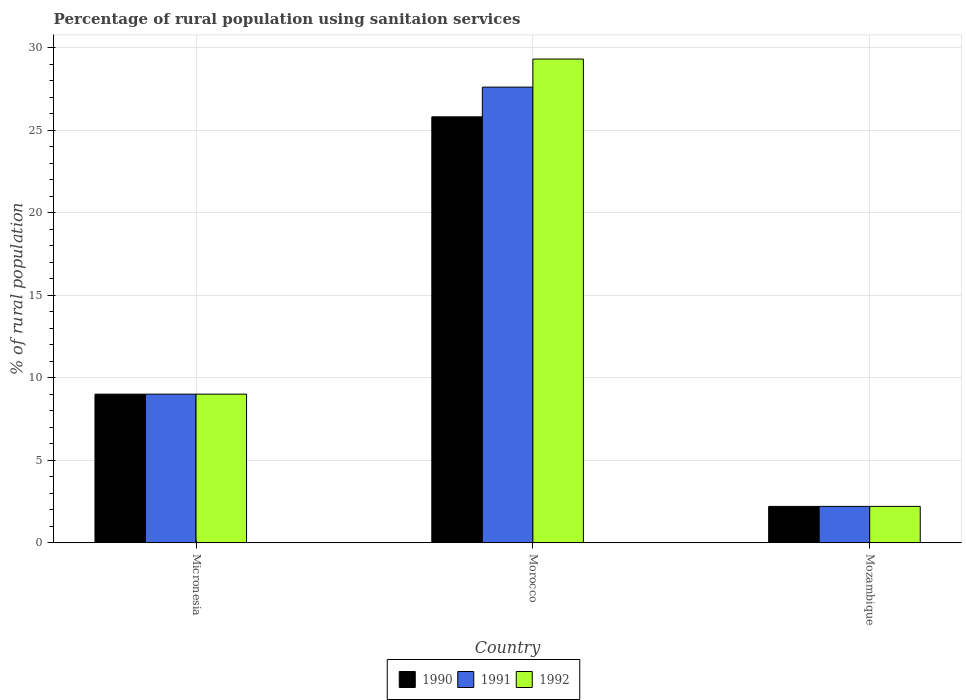How many groups of bars are there?
Your answer should be very brief. 3. How many bars are there on the 1st tick from the left?
Your answer should be very brief. 3. How many bars are there on the 2nd tick from the right?
Your answer should be compact. 3. What is the label of the 2nd group of bars from the left?
Your answer should be compact. Morocco. In how many cases, is the number of bars for a given country not equal to the number of legend labels?
Your answer should be very brief. 0. What is the percentage of rural population using sanitaion services in 1991 in Morocco?
Provide a short and direct response. 27.6. Across all countries, what is the maximum percentage of rural population using sanitaion services in 1992?
Your answer should be very brief. 29.3. In which country was the percentage of rural population using sanitaion services in 1990 maximum?
Your response must be concise. Morocco. In which country was the percentage of rural population using sanitaion services in 1990 minimum?
Offer a terse response. Mozambique. What is the total percentage of rural population using sanitaion services in 1990 in the graph?
Keep it short and to the point. 37. What is the difference between the percentage of rural population using sanitaion services in 1991 in Mozambique and the percentage of rural population using sanitaion services in 1990 in Morocco?
Your answer should be very brief. -23.6. What is the average percentage of rural population using sanitaion services in 1992 per country?
Your response must be concise. 13.5. What is the difference between the percentage of rural population using sanitaion services of/in 1992 and percentage of rural population using sanitaion services of/in 1990 in Mozambique?
Provide a succinct answer. 0. What is the ratio of the percentage of rural population using sanitaion services in 1992 in Morocco to that in Mozambique?
Provide a succinct answer. 13.32. What is the difference between the highest and the second highest percentage of rural population using sanitaion services in 1992?
Offer a very short reply. 6.8. What is the difference between the highest and the lowest percentage of rural population using sanitaion services in 1992?
Ensure brevity in your answer.  27.1. Is the sum of the percentage of rural population using sanitaion services in 1992 in Morocco and Mozambique greater than the maximum percentage of rural population using sanitaion services in 1990 across all countries?
Your answer should be very brief. Yes. What does the 1st bar from the right in Morocco represents?
Give a very brief answer. 1992. Is it the case that in every country, the sum of the percentage of rural population using sanitaion services in 1992 and percentage of rural population using sanitaion services in 1991 is greater than the percentage of rural population using sanitaion services in 1990?
Provide a succinct answer. Yes. Are all the bars in the graph horizontal?
Give a very brief answer. No. How many countries are there in the graph?
Your answer should be very brief. 3. What is the difference between two consecutive major ticks on the Y-axis?
Offer a terse response. 5. Are the values on the major ticks of Y-axis written in scientific E-notation?
Your answer should be compact. No. Does the graph contain any zero values?
Your answer should be very brief. No. How many legend labels are there?
Your answer should be very brief. 3. What is the title of the graph?
Ensure brevity in your answer.  Percentage of rural population using sanitaion services. Does "1990" appear as one of the legend labels in the graph?
Provide a short and direct response. Yes. What is the label or title of the X-axis?
Offer a terse response. Country. What is the label or title of the Y-axis?
Keep it short and to the point. % of rural population. What is the % of rural population of 1991 in Micronesia?
Provide a short and direct response. 9. What is the % of rural population of 1992 in Micronesia?
Provide a succinct answer. 9. What is the % of rural population in 1990 in Morocco?
Make the answer very short. 25.8. What is the % of rural population of 1991 in Morocco?
Give a very brief answer. 27.6. What is the % of rural population in 1992 in Morocco?
Provide a short and direct response. 29.3. What is the % of rural population of 1990 in Mozambique?
Your answer should be compact. 2.2. What is the % of rural population in 1991 in Mozambique?
Offer a terse response. 2.2. What is the % of rural population in 1992 in Mozambique?
Your response must be concise. 2.2. Across all countries, what is the maximum % of rural population in 1990?
Your response must be concise. 25.8. Across all countries, what is the maximum % of rural population in 1991?
Offer a terse response. 27.6. Across all countries, what is the maximum % of rural population in 1992?
Provide a succinct answer. 29.3. Across all countries, what is the minimum % of rural population in 1990?
Provide a succinct answer. 2.2. Across all countries, what is the minimum % of rural population in 1991?
Offer a terse response. 2.2. What is the total % of rural population of 1990 in the graph?
Give a very brief answer. 37. What is the total % of rural population in 1991 in the graph?
Provide a short and direct response. 38.8. What is the total % of rural population in 1992 in the graph?
Your answer should be compact. 40.5. What is the difference between the % of rural population of 1990 in Micronesia and that in Morocco?
Make the answer very short. -16.8. What is the difference between the % of rural population in 1991 in Micronesia and that in Morocco?
Provide a short and direct response. -18.6. What is the difference between the % of rural population of 1992 in Micronesia and that in Morocco?
Your response must be concise. -20.3. What is the difference between the % of rural population of 1990 in Micronesia and that in Mozambique?
Provide a short and direct response. 6.8. What is the difference between the % of rural population in 1991 in Micronesia and that in Mozambique?
Make the answer very short. 6.8. What is the difference between the % of rural population in 1990 in Morocco and that in Mozambique?
Your answer should be very brief. 23.6. What is the difference between the % of rural population of 1991 in Morocco and that in Mozambique?
Ensure brevity in your answer.  25.4. What is the difference between the % of rural population of 1992 in Morocco and that in Mozambique?
Provide a short and direct response. 27.1. What is the difference between the % of rural population of 1990 in Micronesia and the % of rural population of 1991 in Morocco?
Keep it short and to the point. -18.6. What is the difference between the % of rural population of 1990 in Micronesia and the % of rural population of 1992 in Morocco?
Keep it short and to the point. -20.3. What is the difference between the % of rural population in 1991 in Micronesia and the % of rural population in 1992 in Morocco?
Your response must be concise. -20.3. What is the difference between the % of rural population of 1990 in Micronesia and the % of rural population of 1991 in Mozambique?
Ensure brevity in your answer.  6.8. What is the difference between the % of rural population of 1990 in Morocco and the % of rural population of 1991 in Mozambique?
Keep it short and to the point. 23.6. What is the difference between the % of rural population of 1990 in Morocco and the % of rural population of 1992 in Mozambique?
Provide a succinct answer. 23.6. What is the difference between the % of rural population in 1991 in Morocco and the % of rural population in 1992 in Mozambique?
Provide a succinct answer. 25.4. What is the average % of rural population of 1990 per country?
Give a very brief answer. 12.33. What is the average % of rural population of 1991 per country?
Offer a very short reply. 12.93. What is the difference between the % of rural population in 1990 and % of rural population in 1991 in Micronesia?
Provide a succinct answer. 0. What is the difference between the % of rural population in 1990 and % of rural population in 1992 in Micronesia?
Give a very brief answer. 0. What is the difference between the % of rural population of 1991 and % of rural population of 1992 in Micronesia?
Provide a short and direct response. 0. What is the difference between the % of rural population in 1990 and % of rural population in 1992 in Morocco?
Your answer should be very brief. -3.5. What is the difference between the % of rural population of 1990 and % of rural population of 1991 in Mozambique?
Keep it short and to the point. 0. What is the difference between the % of rural population of 1991 and % of rural population of 1992 in Mozambique?
Ensure brevity in your answer.  0. What is the ratio of the % of rural population of 1990 in Micronesia to that in Morocco?
Ensure brevity in your answer.  0.35. What is the ratio of the % of rural population in 1991 in Micronesia to that in Morocco?
Offer a very short reply. 0.33. What is the ratio of the % of rural population in 1992 in Micronesia to that in Morocco?
Your response must be concise. 0.31. What is the ratio of the % of rural population in 1990 in Micronesia to that in Mozambique?
Provide a short and direct response. 4.09. What is the ratio of the % of rural population in 1991 in Micronesia to that in Mozambique?
Make the answer very short. 4.09. What is the ratio of the % of rural population of 1992 in Micronesia to that in Mozambique?
Offer a terse response. 4.09. What is the ratio of the % of rural population in 1990 in Morocco to that in Mozambique?
Provide a short and direct response. 11.73. What is the ratio of the % of rural population of 1991 in Morocco to that in Mozambique?
Make the answer very short. 12.55. What is the ratio of the % of rural population in 1992 in Morocco to that in Mozambique?
Your answer should be compact. 13.32. What is the difference between the highest and the second highest % of rural population in 1990?
Your response must be concise. 16.8. What is the difference between the highest and the second highest % of rural population in 1992?
Give a very brief answer. 20.3. What is the difference between the highest and the lowest % of rural population in 1990?
Keep it short and to the point. 23.6. What is the difference between the highest and the lowest % of rural population of 1991?
Provide a succinct answer. 25.4. What is the difference between the highest and the lowest % of rural population in 1992?
Offer a very short reply. 27.1. 